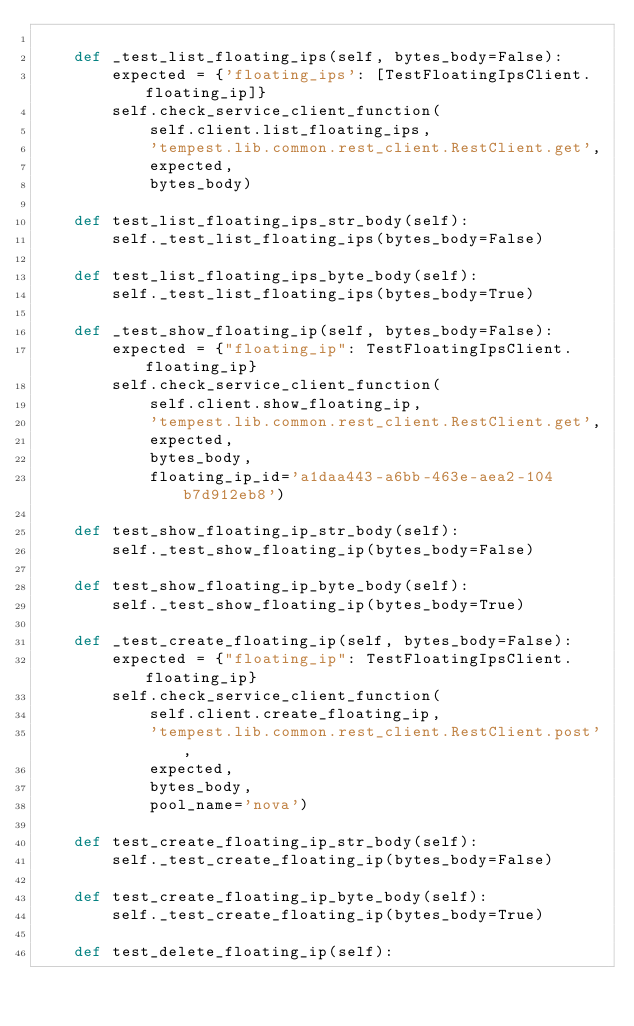<code> <loc_0><loc_0><loc_500><loc_500><_Python_>
    def _test_list_floating_ips(self, bytes_body=False):
        expected = {'floating_ips': [TestFloatingIpsClient.floating_ip]}
        self.check_service_client_function(
            self.client.list_floating_ips,
            'tempest.lib.common.rest_client.RestClient.get',
            expected,
            bytes_body)

    def test_list_floating_ips_str_body(self):
        self._test_list_floating_ips(bytes_body=False)

    def test_list_floating_ips_byte_body(self):
        self._test_list_floating_ips(bytes_body=True)

    def _test_show_floating_ip(self, bytes_body=False):
        expected = {"floating_ip": TestFloatingIpsClient.floating_ip}
        self.check_service_client_function(
            self.client.show_floating_ip,
            'tempest.lib.common.rest_client.RestClient.get',
            expected,
            bytes_body,
            floating_ip_id='a1daa443-a6bb-463e-aea2-104b7d912eb8')

    def test_show_floating_ip_str_body(self):
        self._test_show_floating_ip(bytes_body=False)

    def test_show_floating_ip_byte_body(self):
        self._test_show_floating_ip(bytes_body=True)

    def _test_create_floating_ip(self, bytes_body=False):
        expected = {"floating_ip": TestFloatingIpsClient.floating_ip}
        self.check_service_client_function(
            self.client.create_floating_ip,
            'tempest.lib.common.rest_client.RestClient.post',
            expected,
            bytes_body,
            pool_name='nova')

    def test_create_floating_ip_str_body(self):
        self._test_create_floating_ip(bytes_body=False)

    def test_create_floating_ip_byte_body(self):
        self._test_create_floating_ip(bytes_body=True)

    def test_delete_floating_ip(self):</code> 